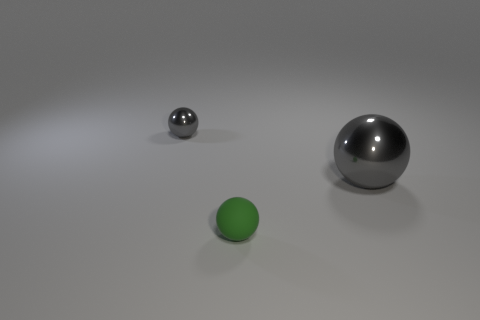Subtract all red cubes. How many gray spheres are left? 2 Add 2 large red objects. How many objects exist? 5 Subtract all tiny green balls. How many balls are left? 2 Subtract all blue spheres. Subtract all yellow cylinders. How many spheres are left? 3 Subtract all small rubber things. Subtract all tiny gray spheres. How many objects are left? 1 Add 1 small green rubber balls. How many small green rubber balls are left? 2 Add 2 brown metallic things. How many brown metallic things exist? 2 Subtract 0 gray cubes. How many objects are left? 3 